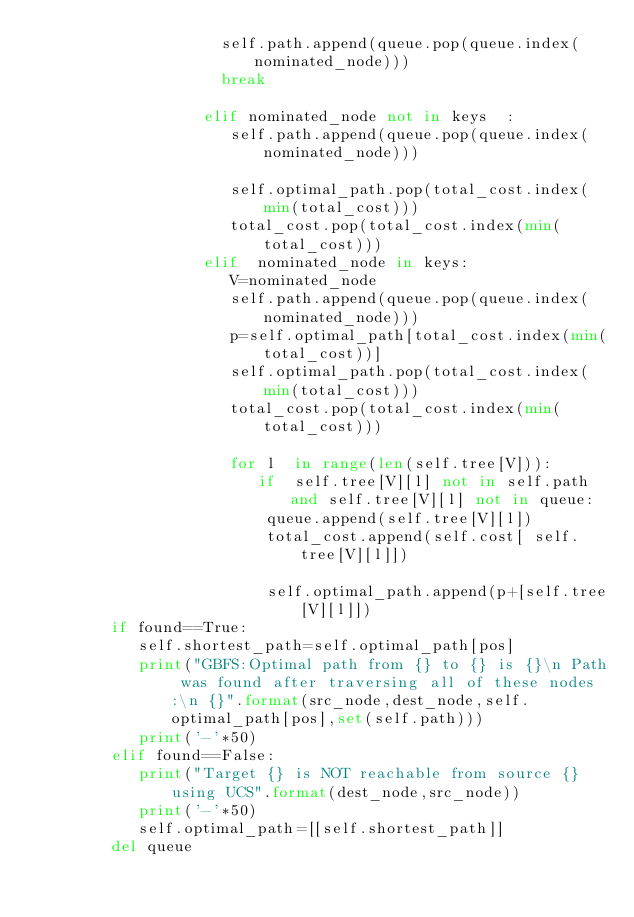<code> <loc_0><loc_0><loc_500><loc_500><_Python_>                    self.path.append(queue.pop(queue.index(nominated_node)))  
                    break
                    
                  elif nominated_node not in keys  :
                     self.path.append(queue.pop(queue.index(nominated_node))) 
                     
                     self.optimal_path.pop(total_cost.index(min(total_cost)))
                     total_cost.pop(total_cost.index(min(total_cost)))
                  elif  nominated_node in keys:
                     V=nominated_node
                     self.path.append(queue.pop(queue.index(nominated_node)))
                     p=self.optimal_path[total_cost.index(min(total_cost))]
                     self.optimal_path.pop(total_cost.index(min(total_cost)))                
                     total_cost.pop(total_cost.index(min(total_cost)))
                     
                     for l  in range(len(self.tree[V])):
                        if  self.tree[V][l] not in self.path and self.tree[V][l] not in queue:
                         queue.append(self.tree[V][l])
                         total_cost.append(self.cost[ self.tree[V][l]]) 

                         self.optimal_path.append(p+[self.tree[V][l]])
        if found==True:
           self.shortest_path=self.optimal_path[pos]
           print("GBFS:Optimal path from {} to {} is {}\n Path was found after traversing all of these nodes:\n {}".format(src_node,dest_node,self.optimal_path[pos],set(self.path)))
           print('-'*50)
        elif found==False:
           print("Target {} is NOT reachable from source {}  using UCS".format(dest_node,src_node)) 
           print('-'*50) 
           self.optimal_path=[[self.shortest_path]]
        del queue
</code> 